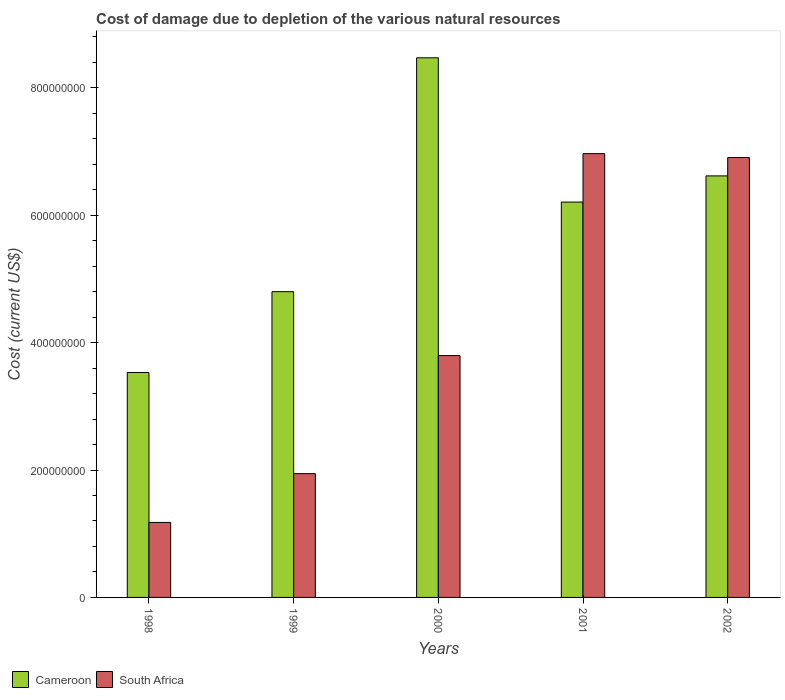How many groups of bars are there?
Your response must be concise. 5. Are the number of bars per tick equal to the number of legend labels?
Give a very brief answer. Yes. How many bars are there on the 2nd tick from the left?
Provide a succinct answer. 2. What is the cost of damage caused due to the depletion of various natural resources in Cameroon in 2000?
Give a very brief answer. 8.47e+08. Across all years, what is the maximum cost of damage caused due to the depletion of various natural resources in Cameroon?
Your response must be concise. 8.47e+08. Across all years, what is the minimum cost of damage caused due to the depletion of various natural resources in South Africa?
Offer a very short reply. 1.18e+08. In which year was the cost of damage caused due to the depletion of various natural resources in South Africa minimum?
Ensure brevity in your answer.  1998. What is the total cost of damage caused due to the depletion of various natural resources in South Africa in the graph?
Your answer should be very brief. 2.08e+09. What is the difference between the cost of damage caused due to the depletion of various natural resources in South Africa in 1999 and that in 2001?
Give a very brief answer. -5.02e+08. What is the difference between the cost of damage caused due to the depletion of various natural resources in Cameroon in 2002 and the cost of damage caused due to the depletion of various natural resources in South Africa in 1999?
Your answer should be very brief. 4.67e+08. What is the average cost of damage caused due to the depletion of various natural resources in South Africa per year?
Your response must be concise. 4.16e+08. In the year 1998, what is the difference between the cost of damage caused due to the depletion of various natural resources in South Africa and cost of damage caused due to the depletion of various natural resources in Cameroon?
Your answer should be very brief. -2.35e+08. In how many years, is the cost of damage caused due to the depletion of various natural resources in Cameroon greater than 800000000 US$?
Give a very brief answer. 1. What is the ratio of the cost of damage caused due to the depletion of various natural resources in Cameroon in 2001 to that in 2002?
Keep it short and to the point. 0.94. Is the cost of damage caused due to the depletion of various natural resources in Cameroon in 2001 less than that in 2002?
Your answer should be very brief. Yes. Is the difference between the cost of damage caused due to the depletion of various natural resources in South Africa in 1998 and 2002 greater than the difference between the cost of damage caused due to the depletion of various natural resources in Cameroon in 1998 and 2002?
Keep it short and to the point. No. What is the difference between the highest and the second highest cost of damage caused due to the depletion of various natural resources in South Africa?
Provide a short and direct response. 6.14e+06. What is the difference between the highest and the lowest cost of damage caused due to the depletion of various natural resources in South Africa?
Provide a short and direct response. 5.79e+08. In how many years, is the cost of damage caused due to the depletion of various natural resources in South Africa greater than the average cost of damage caused due to the depletion of various natural resources in South Africa taken over all years?
Offer a very short reply. 2. Is the sum of the cost of damage caused due to the depletion of various natural resources in South Africa in 1999 and 2002 greater than the maximum cost of damage caused due to the depletion of various natural resources in Cameroon across all years?
Your answer should be compact. Yes. What does the 1st bar from the left in 2002 represents?
Your answer should be very brief. Cameroon. What does the 2nd bar from the right in 2000 represents?
Give a very brief answer. Cameroon. How many years are there in the graph?
Your response must be concise. 5. What is the difference between two consecutive major ticks on the Y-axis?
Offer a very short reply. 2.00e+08. Are the values on the major ticks of Y-axis written in scientific E-notation?
Keep it short and to the point. No. Does the graph contain grids?
Ensure brevity in your answer.  No. How many legend labels are there?
Provide a succinct answer. 2. What is the title of the graph?
Provide a short and direct response. Cost of damage due to depletion of the various natural resources. Does "San Marino" appear as one of the legend labels in the graph?
Offer a very short reply. No. What is the label or title of the Y-axis?
Ensure brevity in your answer.  Cost (current US$). What is the Cost (current US$) in Cameroon in 1998?
Your answer should be very brief. 3.53e+08. What is the Cost (current US$) in South Africa in 1998?
Your response must be concise. 1.18e+08. What is the Cost (current US$) of Cameroon in 1999?
Offer a terse response. 4.80e+08. What is the Cost (current US$) of South Africa in 1999?
Keep it short and to the point. 1.94e+08. What is the Cost (current US$) of Cameroon in 2000?
Provide a succinct answer. 8.47e+08. What is the Cost (current US$) in South Africa in 2000?
Provide a succinct answer. 3.80e+08. What is the Cost (current US$) in Cameroon in 2001?
Give a very brief answer. 6.21e+08. What is the Cost (current US$) in South Africa in 2001?
Your response must be concise. 6.97e+08. What is the Cost (current US$) in Cameroon in 2002?
Offer a terse response. 6.62e+08. What is the Cost (current US$) in South Africa in 2002?
Provide a succinct answer. 6.91e+08. Across all years, what is the maximum Cost (current US$) of Cameroon?
Make the answer very short. 8.47e+08. Across all years, what is the maximum Cost (current US$) of South Africa?
Offer a terse response. 6.97e+08. Across all years, what is the minimum Cost (current US$) of Cameroon?
Offer a very short reply. 3.53e+08. Across all years, what is the minimum Cost (current US$) of South Africa?
Make the answer very short. 1.18e+08. What is the total Cost (current US$) of Cameroon in the graph?
Your response must be concise. 2.96e+09. What is the total Cost (current US$) of South Africa in the graph?
Ensure brevity in your answer.  2.08e+09. What is the difference between the Cost (current US$) of Cameroon in 1998 and that in 1999?
Offer a terse response. -1.27e+08. What is the difference between the Cost (current US$) in South Africa in 1998 and that in 1999?
Provide a short and direct response. -7.66e+07. What is the difference between the Cost (current US$) of Cameroon in 1998 and that in 2000?
Offer a terse response. -4.94e+08. What is the difference between the Cost (current US$) of South Africa in 1998 and that in 2000?
Offer a terse response. -2.62e+08. What is the difference between the Cost (current US$) in Cameroon in 1998 and that in 2001?
Make the answer very short. -2.68e+08. What is the difference between the Cost (current US$) of South Africa in 1998 and that in 2001?
Your answer should be compact. -5.79e+08. What is the difference between the Cost (current US$) in Cameroon in 1998 and that in 2002?
Provide a short and direct response. -3.09e+08. What is the difference between the Cost (current US$) in South Africa in 1998 and that in 2002?
Your answer should be compact. -5.73e+08. What is the difference between the Cost (current US$) in Cameroon in 1999 and that in 2000?
Offer a terse response. -3.67e+08. What is the difference between the Cost (current US$) of South Africa in 1999 and that in 2000?
Offer a very short reply. -1.85e+08. What is the difference between the Cost (current US$) in Cameroon in 1999 and that in 2001?
Offer a terse response. -1.41e+08. What is the difference between the Cost (current US$) of South Africa in 1999 and that in 2001?
Give a very brief answer. -5.02e+08. What is the difference between the Cost (current US$) of Cameroon in 1999 and that in 2002?
Your answer should be compact. -1.82e+08. What is the difference between the Cost (current US$) in South Africa in 1999 and that in 2002?
Offer a very short reply. -4.96e+08. What is the difference between the Cost (current US$) in Cameroon in 2000 and that in 2001?
Offer a very short reply. 2.26e+08. What is the difference between the Cost (current US$) in South Africa in 2000 and that in 2001?
Provide a succinct answer. -3.17e+08. What is the difference between the Cost (current US$) in Cameroon in 2000 and that in 2002?
Provide a short and direct response. 1.85e+08. What is the difference between the Cost (current US$) in South Africa in 2000 and that in 2002?
Make the answer very short. -3.11e+08. What is the difference between the Cost (current US$) in Cameroon in 2001 and that in 2002?
Your answer should be compact. -4.11e+07. What is the difference between the Cost (current US$) of South Africa in 2001 and that in 2002?
Your answer should be compact. 6.14e+06. What is the difference between the Cost (current US$) in Cameroon in 1998 and the Cost (current US$) in South Africa in 1999?
Your answer should be compact. 1.59e+08. What is the difference between the Cost (current US$) in Cameroon in 1998 and the Cost (current US$) in South Africa in 2000?
Keep it short and to the point. -2.66e+07. What is the difference between the Cost (current US$) in Cameroon in 1998 and the Cost (current US$) in South Africa in 2001?
Ensure brevity in your answer.  -3.44e+08. What is the difference between the Cost (current US$) in Cameroon in 1998 and the Cost (current US$) in South Africa in 2002?
Give a very brief answer. -3.37e+08. What is the difference between the Cost (current US$) of Cameroon in 1999 and the Cost (current US$) of South Africa in 2000?
Offer a very short reply. 1.00e+08. What is the difference between the Cost (current US$) of Cameroon in 1999 and the Cost (current US$) of South Africa in 2001?
Provide a succinct answer. -2.17e+08. What is the difference between the Cost (current US$) in Cameroon in 1999 and the Cost (current US$) in South Africa in 2002?
Offer a terse response. -2.11e+08. What is the difference between the Cost (current US$) of Cameroon in 2000 and the Cost (current US$) of South Africa in 2001?
Give a very brief answer. 1.50e+08. What is the difference between the Cost (current US$) of Cameroon in 2000 and the Cost (current US$) of South Africa in 2002?
Offer a very short reply. 1.57e+08. What is the difference between the Cost (current US$) in Cameroon in 2001 and the Cost (current US$) in South Africa in 2002?
Make the answer very short. -6.99e+07. What is the average Cost (current US$) in Cameroon per year?
Ensure brevity in your answer.  5.93e+08. What is the average Cost (current US$) in South Africa per year?
Your answer should be very brief. 4.16e+08. In the year 1998, what is the difference between the Cost (current US$) in Cameroon and Cost (current US$) in South Africa?
Your answer should be compact. 2.35e+08. In the year 1999, what is the difference between the Cost (current US$) of Cameroon and Cost (current US$) of South Africa?
Make the answer very short. 2.86e+08. In the year 2000, what is the difference between the Cost (current US$) of Cameroon and Cost (current US$) of South Africa?
Your answer should be very brief. 4.67e+08. In the year 2001, what is the difference between the Cost (current US$) in Cameroon and Cost (current US$) in South Africa?
Make the answer very short. -7.60e+07. In the year 2002, what is the difference between the Cost (current US$) of Cameroon and Cost (current US$) of South Africa?
Your answer should be very brief. -2.88e+07. What is the ratio of the Cost (current US$) of Cameroon in 1998 to that in 1999?
Ensure brevity in your answer.  0.74. What is the ratio of the Cost (current US$) in South Africa in 1998 to that in 1999?
Make the answer very short. 0.61. What is the ratio of the Cost (current US$) of Cameroon in 1998 to that in 2000?
Make the answer very short. 0.42. What is the ratio of the Cost (current US$) of South Africa in 1998 to that in 2000?
Your answer should be very brief. 0.31. What is the ratio of the Cost (current US$) of Cameroon in 1998 to that in 2001?
Make the answer very short. 0.57. What is the ratio of the Cost (current US$) of South Africa in 1998 to that in 2001?
Your response must be concise. 0.17. What is the ratio of the Cost (current US$) in Cameroon in 1998 to that in 2002?
Provide a succinct answer. 0.53. What is the ratio of the Cost (current US$) in South Africa in 1998 to that in 2002?
Your answer should be very brief. 0.17. What is the ratio of the Cost (current US$) in Cameroon in 1999 to that in 2000?
Keep it short and to the point. 0.57. What is the ratio of the Cost (current US$) of South Africa in 1999 to that in 2000?
Make the answer very short. 0.51. What is the ratio of the Cost (current US$) of Cameroon in 1999 to that in 2001?
Provide a succinct answer. 0.77. What is the ratio of the Cost (current US$) of South Africa in 1999 to that in 2001?
Give a very brief answer. 0.28. What is the ratio of the Cost (current US$) in Cameroon in 1999 to that in 2002?
Offer a very short reply. 0.73. What is the ratio of the Cost (current US$) of South Africa in 1999 to that in 2002?
Keep it short and to the point. 0.28. What is the ratio of the Cost (current US$) in Cameroon in 2000 to that in 2001?
Provide a short and direct response. 1.36. What is the ratio of the Cost (current US$) of South Africa in 2000 to that in 2001?
Offer a very short reply. 0.55. What is the ratio of the Cost (current US$) of Cameroon in 2000 to that in 2002?
Provide a succinct answer. 1.28. What is the ratio of the Cost (current US$) in South Africa in 2000 to that in 2002?
Your answer should be compact. 0.55. What is the ratio of the Cost (current US$) in Cameroon in 2001 to that in 2002?
Make the answer very short. 0.94. What is the ratio of the Cost (current US$) in South Africa in 2001 to that in 2002?
Make the answer very short. 1.01. What is the difference between the highest and the second highest Cost (current US$) of Cameroon?
Provide a succinct answer. 1.85e+08. What is the difference between the highest and the second highest Cost (current US$) of South Africa?
Ensure brevity in your answer.  6.14e+06. What is the difference between the highest and the lowest Cost (current US$) in Cameroon?
Your answer should be very brief. 4.94e+08. What is the difference between the highest and the lowest Cost (current US$) of South Africa?
Your answer should be very brief. 5.79e+08. 